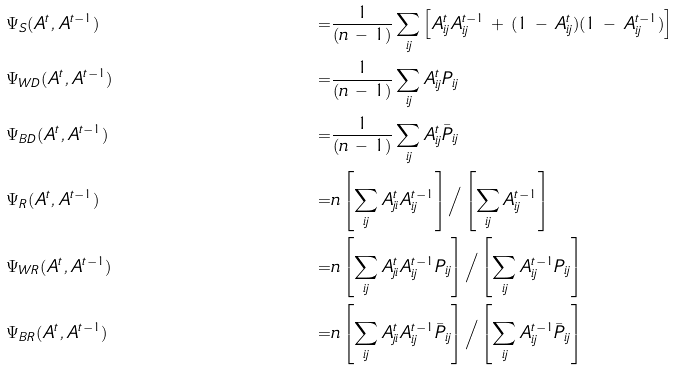Convert formula to latex. <formula><loc_0><loc_0><loc_500><loc_500>& \Psi _ { S } ( A ^ { t } , A ^ { t - 1 } ) & = & \frac { 1 } { ( n \, - \, 1 ) } \sum _ { i j } \left [ A _ { i j } ^ { t } A _ { i j } ^ { t - 1 } \, + \, ( 1 \, - \, A _ { i j } ^ { t } ) ( 1 \, - \, A _ { i j } ^ { t - 1 } ) \right ] \\ & \Psi _ { W D } ( A ^ { t } , A ^ { t - 1 } ) & = & \frac { 1 } { ( n \, - \, 1 ) } \sum _ { i j } A _ { i j } ^ { t } P _ { i j } \\ & \Psi _ { B D } ( A ^ { t } , A ^ { t - 1 } ) & = & \frac { 1 } { ( n \, - \, 1 ) } \sum _ { i j } A _ { i j } ^ { t } \bar { P } _ { i j } \\ & \Psi _ { R } ( A ^ { t } , A ^ { t - 1 } ) & = & n \left [ \sum _ { i j } A _ { j i } ^ { t } A _ { i j } ^ { t - 1 } \right ] \Big / \left [ \sum _ { i j } A _ { i j } ^ { t - 1 } \right ] \\ & \Psi _ { W R } ( A ^ { t } , A ^ { t - 1 } ) & = & n \left [ \sum _ { i j } A _ { j i } ^ { t } A _ { i j } ^ { t - 1 } P _ { i j } \right ] \Big / \left [ \sum _ { i j } A _ { i j } ^ { t - 1 } P _ { i j } \right ] \\ & \Psi _ { B R } ( A ^ { t } , A ^ { t - 1 } ) & = & n \left [ \sum _ { i j } A _ { j i } ^ { t } A _ { i j } ^ { t - 1 } \bar { P } _ { i j } \right ] \Big / \left [ \sum _ { i j } A _ { i j } ^ { t - 1 } \bar { P } _ { i j } \right ] \\</formula> 